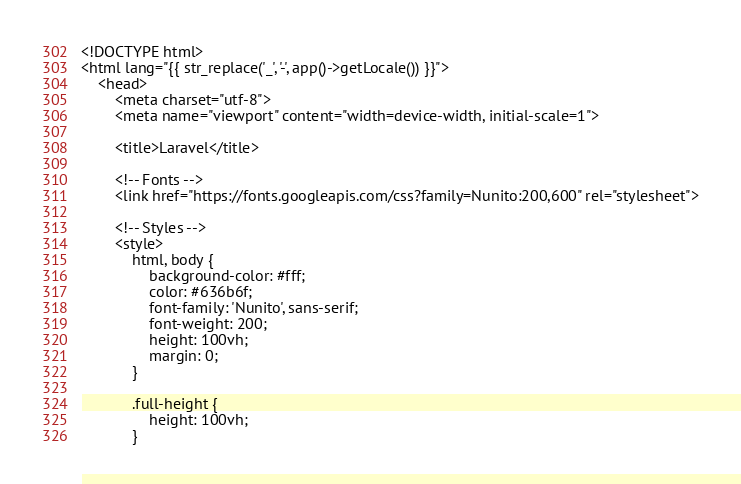Convert code to text. <code><loc_0><loc_0><loc_500><loc_500><_PHP_><!DOCTYPE html>
<html lang="{{ str_replace('_', '-', app()->getLocale()) }}">
    <head>
        <meta charset="utf-8">
        <meta name="viewport" content="width=device-width, initial-scale=1">

        <title>Laravel</title>

        <!-- Fonts -->
        <link href="https://fonts.googleapis.com/css?family=Nunito:200,600" rel="stylesheet">

        <!-- Styles -->
        <style>
            html, body {
                background-color: #fff;
                color: #636b6f;
                font-family: 'Nunito', sans-serif;
                font-weight: 200;
                height: 100vh;
                margin: 0;
            }

            .full-height {
                height: 100vh;
            }
</code> 